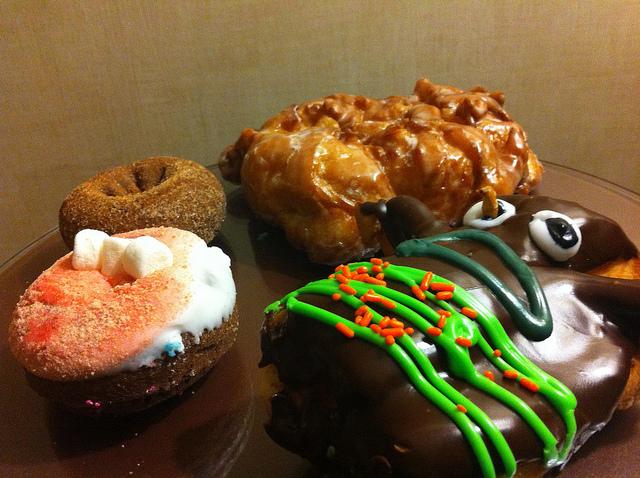Where are the food on?
Keep it brief. Plate. Could all the things shown be part of the same category of food?
Keep it brief. Yes. What is in the eye of the doughnut?
Keep it brief. Pretzel. 